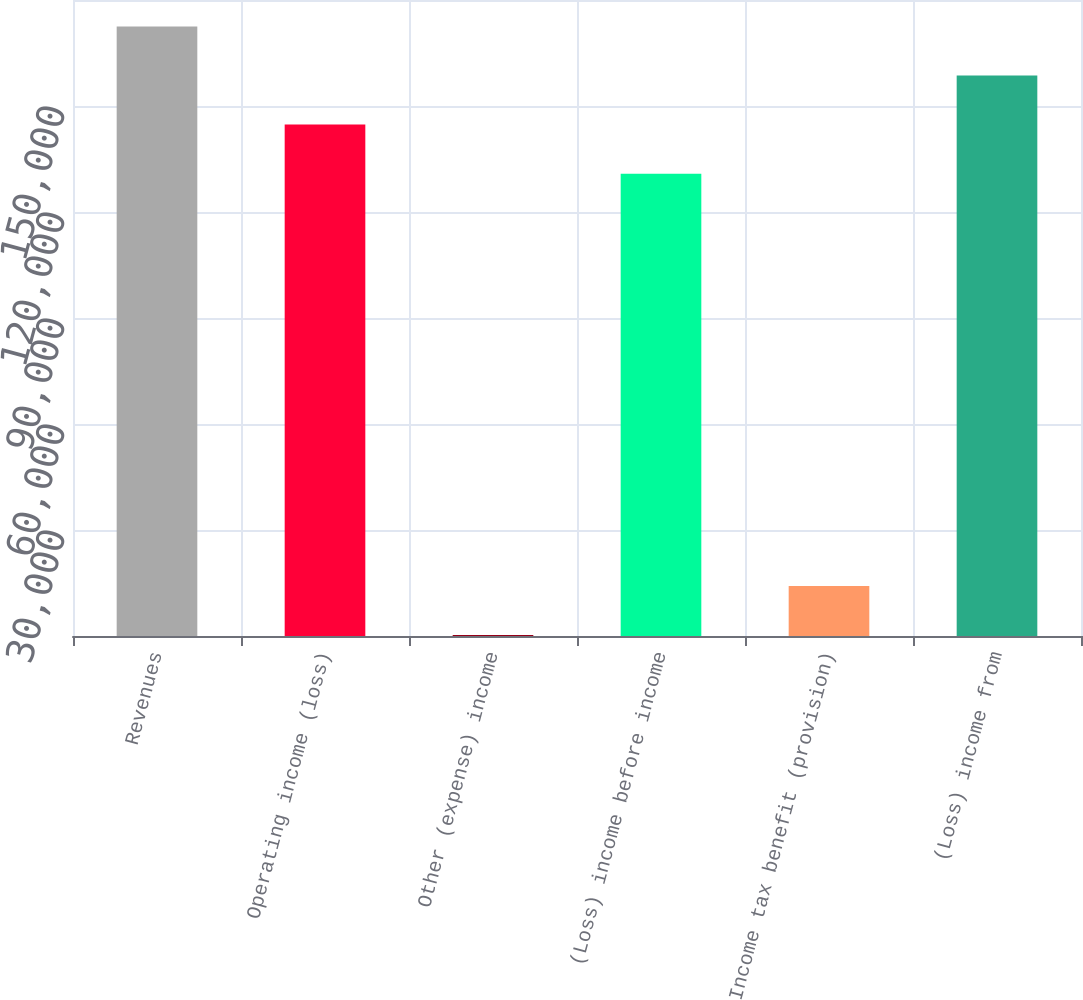<chart> <loc_0><loc_0><loc_500><loc_500><bar_chart><fcel>Revenues<fcel>Operating income (loss)<fcel>Other (expense) income<fcel>(Loss) income before income<fcel>Income tax benefit (provision)<fcel>(Loss) income from<nl><fcel>172525<fcel>144736<fcel>275<fcel>130842<fcel>14169.3<fcel>158631<nl></chart> 